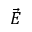Convert formula to latex. <formula><loc_0><loc_0><loc_500><loc_500>\vec { E }</formula> 